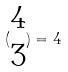<formula> <loc_0><loc_0><loc_500><loc_500>( \begin{matrix} 4 \\ 3 \end{matrix} ) = 4</formula> 